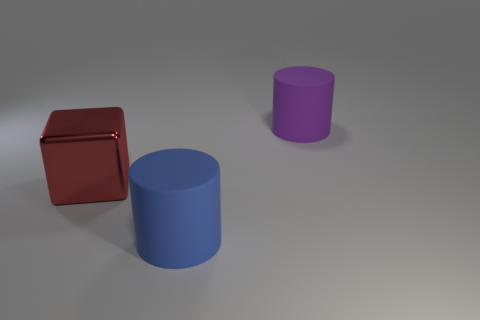Is there any other thing that has the same shape as the big red thing?
Your answer should be compact. No. How many small objects are cylinders or blocks?
Offer a very short reply. 0. There is a blue object that is the same size as the purple thing; what shape is it?
Make the answer very short. Cylinder. How many objects are either cylinders that are in front of the red object or red blocks?
Provide a succinct answer. 2. Is the number of red blocks that are in front of the large blue cylinder greater than the number of big red metallic objects to the right of the large red thing?
Your answer should be compact. No. Do the big blue cylinder and the cube have the same material?
Ensure brevity in your answer.  No. There is a big object that is behind the large blue matte cylinder and on the right side of the big red cube; what shape is it?
Your response must be concise. Cylinder. What is the shape of the purple object that is made of the same material as the large blue object?
Your response must be concise. Cylinder. Are there any red cylinders?
Your response must be concise. No. There is a large object behind the large red metal object; are there any blue cylinders left of it?
Your answer should be compact. Yes. 